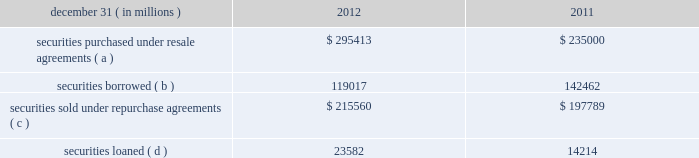Jpmorgan chase & co./2012 annual report 249 note 13 2013 securities financing activities jpmorgan chase enters into resale agreements , repurchase agreements , securities borrowed transactions and securities loaned transactions ( collectively , 201csecurities financing agreements 201d ) primarily to finance the firm 2019s inventory positions , acquire securities to cover short positions , accommodate customers 2019 financing needs , and settle other securities obligations .
Securities financing agreements are treated as collateralized financings on the firm 2019s consolidated balance sheets .
Resale and repurchase agreements are generally carried at the amounts at which the securities will be subsequently sold or repurchased , plus accrued interest .
Securities borrowed and securities loaned transactions are generally carried at the amount of cash collateral advanced or received .
Where appropriate under applicable accounting guidance , resale and repurchase agreements with the same counterparty are reported on a net basis .
Fees received and paid in connection with securities financing agreements are recorded in interest income and interest expense , respectively .
The firm has elected the fair value option for certain securities financing agreements .
For further information regarding the fair value option , see note 4 on pages 214 2013 216 of this annual report .
The securities financing agreements for which the fair value option has been elected are reported within securities purchased under resale agreements ; securities loaned or sold under repurchase agreements ; and securities borrowed on the consolidated balance sheets .
Generally , for agreements carried at fair value , current-period interest accruals are recorded within interest income and interest expense , with changes in fair value reported in principal transactions revenue .
However , for financial instruments containing embedded derivatives that would be separately accounted for in accordance with accounting guidance for hybrid instruments , all changes in fair value , including any interest elements , are reported in principal transactions revenue .
The table details the firm 2019s securities financing agreements , all of which are accounted for as collateralized financings during the periods presented .
December 31 , ( in millions ) 2012 2011 securities purchased under resale agreements ( a ) $ 295413 $ 235000 securities borrowed ( b ) 119017 142462 securities sold under repurchase agreements ( c ) $ 215560 $ 197789 securities loaned ( d ) 23582 14214 ( a ) at december 31 , 2012 and 2011 , included resale agreements of $ 24.3 billion and $ 22.2 billion , respectively , accounted for at fair value .
( b ) at december 31 , 2012 and 2011 , included securities borrowed of $ 10.2 billion and $ 15.3 billion , respectively , accounted for at fair value .
( c ) at december 31 , 2012 and 2011 , included repurchase agreements of $ 3.9 billion and $ 6.8 billion , respectively , accounted for at fair value .
( d ) at december 31 , 2012 , included securities loaned of $ 457 million accounted for at fair value .
There were no securities loaned accounted for at fair value at december 31 , 2011 .
The amounts reported in the table above were reduced by $ 96.9 billion and $ 115.7 billion at december 31 , 2012 and 2011 , respectively , as a result of agreements in effect that meet the specified conditions for net presentation under applicable accounting guidance .
Jpmorgan chase 2019s policy is to take possession , where possible , of securities purchased under resale agreements and of securities borrowed .
The firm monitors the value of the underlying securities ( primarily g7 government securities , u.s .
Agency securities and agency mbs , and equities ) that it has received from its counterparties and either requests additional collateral or returns a portion of the collateral when appropriate in light of the market value of the underlying securities .
Margin levels are established initially based upon the counterparty and type of collateral and monitored on an ongoing basis to protect against declines in collateral value in the event of default .
Jpmorgan chase typically enters into master netting agreements and other collateral arrangements with its resale agreement and securities borrowed counterparties , which provide for the right to liquidate the purchased or borrowed securities in the event of a customer default .
As a result of the firm 2019s credit risk mitigation practices with respect to resale and securities borrowed agreements as described above , the firm did not hold any reserves for credit impairment with respect to these agreements as of december 31 , 2012 and for further information regarding assets pledged and collateral received in securities financing agreements , see note 30 on pages 315 2013316 of this annual report. .
Jpmorgan chase & co./2012 annual report 249 note 13 2013 securities financing activities jpmorgan chase enters into resale agreements , repurchase agreements , securities borrowed transactions and securities loaned transactions ( collectively , 201csecurities financing agreements 201d ) primarily to finance the firm 2019s inventory positions , acquire securities to cover short positions , accommodate customers 2019 financing needs , and settle other securities obligations .
Securities financing agreements are treated as collateralized financings on the firm 2019s consolidated balance sheets .
Resale and repurchase agreements are generally carried at the amounts at which the securities will be subsequently sold or repurchased , plus accrued interest .
Securities borrowed and securities loaned transactions are generally carried at the amount of cash collateral advanced or received .
Where appropriate under applicable accounting guidance , resale and repurchase agreements with the same counterparty are reported on a net basis .
Fees received and paid in connection with securities financing agreements are recorded in interest income and interest expense , respectively .
The firm has elected the fair value option for certain securities financing agreements .
For further information regarding the fair value option , see note 4 on pages 214 2013 216 of this annual report .
The securities financing agreements for which the fair value option has been elected are reported within securities purchased under resale agreements ; securities loaned or sold under repurchase agreements ; and securities borrowed on the consolidated balance sheets .
Generally , for agreements carried at fair value , current-period interest accruals are recorded within interest income and interest expense , with changes in fair value reported in principal transactions revenue .
However , for financial instruments containing embedded derivatives that would be separately accounted for in accordance with accounting guidance for hybrid instruments , all changes in fair value , including any interest elements , are reported in principal transactions revenue .
The following table details the firm 2019s securities financing agreements , all of which are accounted for as collateralized financings during the periods presented .
December 31 , ( in millions ) 2012 2011 securities purchased under resale agreements ( a ) $ 295413 $ 235000 securities borrowed ( b ) 119017 142462 securities sold under repurchase agreements ( c ) $ 215560 $ 197789 securities loaned ( d ) 23582 14214 ( a ) at december 31 , 2012 and 2011 , included resale agreements of $ 24.3 billion and $ 22.2 billion , respectively , accounted for at fair value .
( b ) at december 31 , 2012 and 2011 , included securities borrowed of $ 10.2 billion and $ 15.3 billion , respectively , accounted for at fair value .
( c ) at december 31 , 2012 and 2011 , included repurchase agreements of $ 3.9 billion and $ 6.8 billion , respectively , accounted for at fair value .
( d ) at december 31 , 2012 , included securities loaned of $ 457 million accounted for at fair value .
There were no securities loaned accounted for at fair value at december 31 , 2011 .
The amounts reported in the table above were reduced by $ 96.9 billion and $ 115.7 billion at december 31 , 2012 and 2011 , respectively , as a result of agreements in effect that meet the specified conditions for net presentation under applicable accounting guidance .
Jpmorgan chase 2019s policy is to take possession , where possible , of securities purchased under resale agreements and of securities borrowed .
The firm monitors the value of the underlying securities ( primarily g7 government securities , u.s .
Agency securities and agency mbs , and equities ) that it has received from its counterparties and either requests additional collateral or returns a portion of the collateral when appropriate in light of the market value of the underlying securities .
Margin levels are established initially based upon the counterparty and type of collateral and monitored on an ongoing basis to protect against declines in collateral value in the event of default .
Jpmorgan chase typically enters into master netting agreements and other collateral arrangements with its resale agreement and securities borrowed counterparties , which provide for the right to liquidate the purchased or borrowed securities in the event of a customer default .
As a result of the firm 2019s credit risk mitigation practices with respect to resale and securities borrowed agreements as described above , the firm did not hold any reserves for credit impairment with respect to these agreements as of december 31 , 2012 and for further information regarding assets pledged and collateral received in securities financing agreements , see note 30 on pages 315 2013316 of this annual report. .
In 2012 , securities borrowed were what percent of securities loaned? 
Computations: (119017 / 23582)
Answer: 5.04694. 